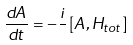Convert formula to latex. <formula><loc_0><loc_0><loc_500><loc_500>\frac { d A } { d t } = - \frac { i } { } \left [ A , H _ { t o t } \right ]</formula> 